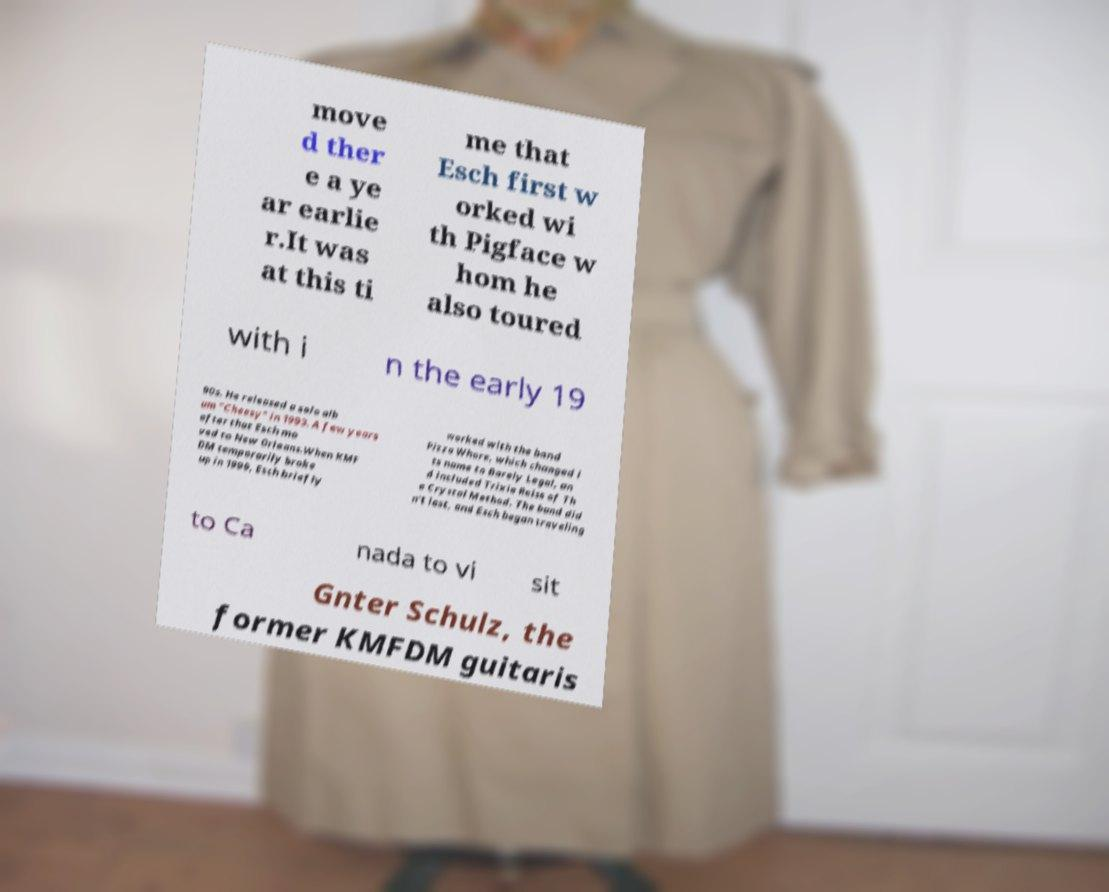Could you assist in decoding the text presented in this image and type it out clearly? move d ther e a ye ar earlie r.It was at this ti me that Esch first w orked wi th Pigface w hom he also toured with i n the early 19 90s. He released a solo alb um "Cheesy" in 1993. A few years after that Esch mo ved to New Orleans.When KMF DM temporarily broke up in 1999, Esch briefly worked with the band Pizza Whore, which changed i ts name to Barely Legal, an d included Trixie Reiss of Th e Crystal Method. The band did n't last, and Esch began traveling to Ca nada to vi sit Gnter Schulz, the former KMFDM guitaris 